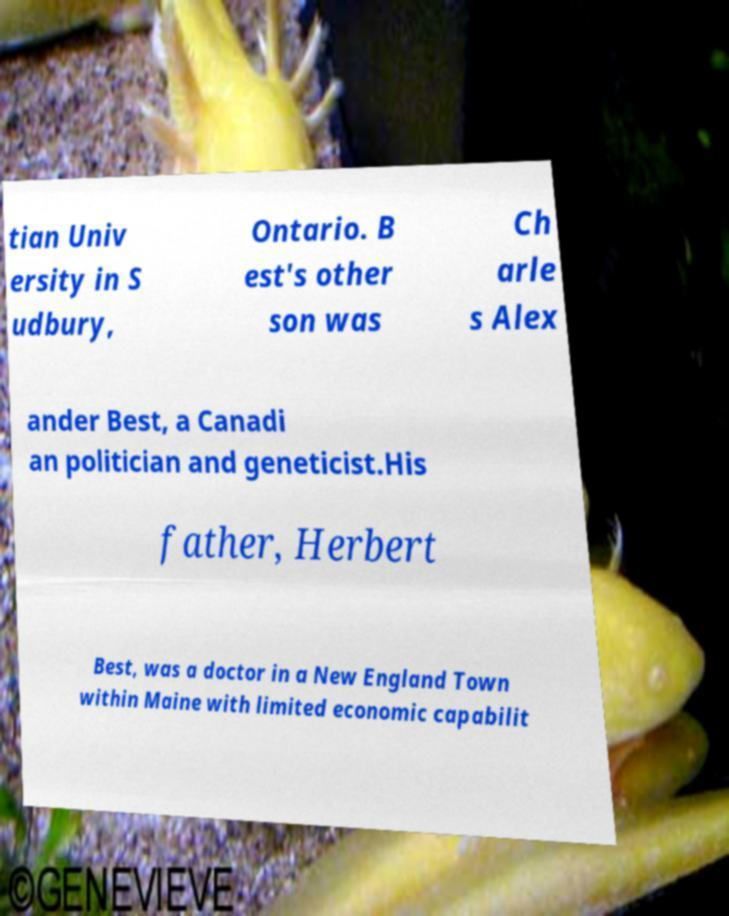For documentation purposes, I need the text within this image transcribed. Could you provide that? tian Univ ersity in S udbury, Ontario. B est's other son was Ch arle s Alex ander Best, a Canadi an politician and geneticist.His father, Herbert Best, was a doctor in a New England Town within Maine with limited economic capabilit 